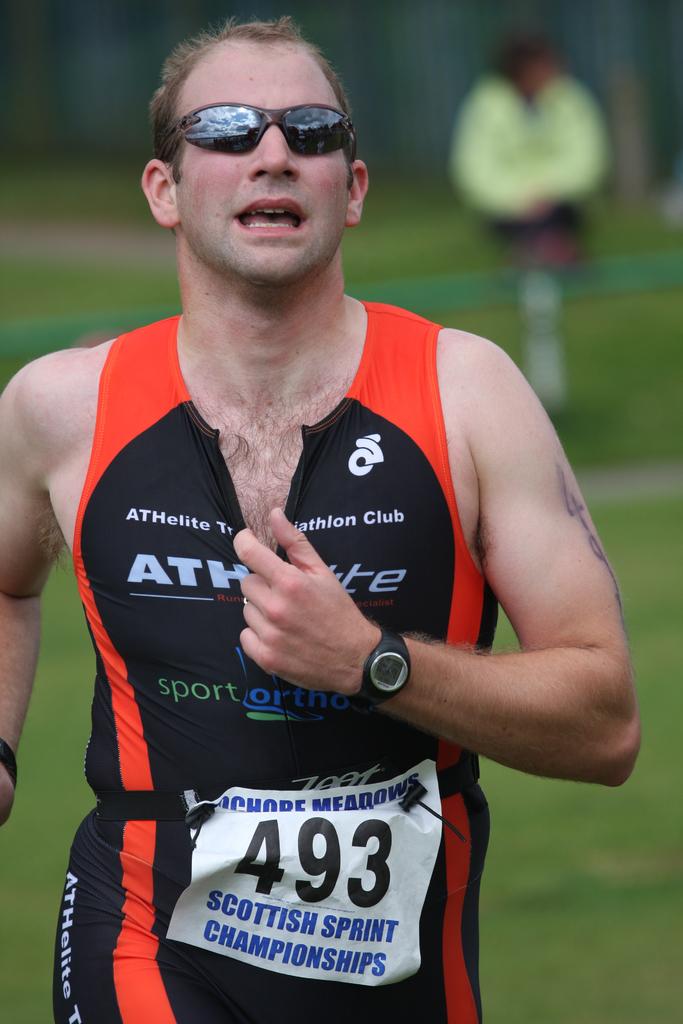What is his humber?
Offer a terse response. 493. 